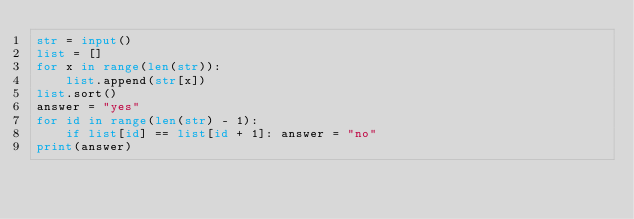<code> <loc_0><loc_0><loc_500><loc_500><_Python_>str = input()
list = []
for x in range(len(str)):
    list.append(str[x])
list.sort()
answer = "yes"
for id in range(len(str) - 1):
    if list[id] == list[id + 1]: answer = "no"
print(answer)</code> 